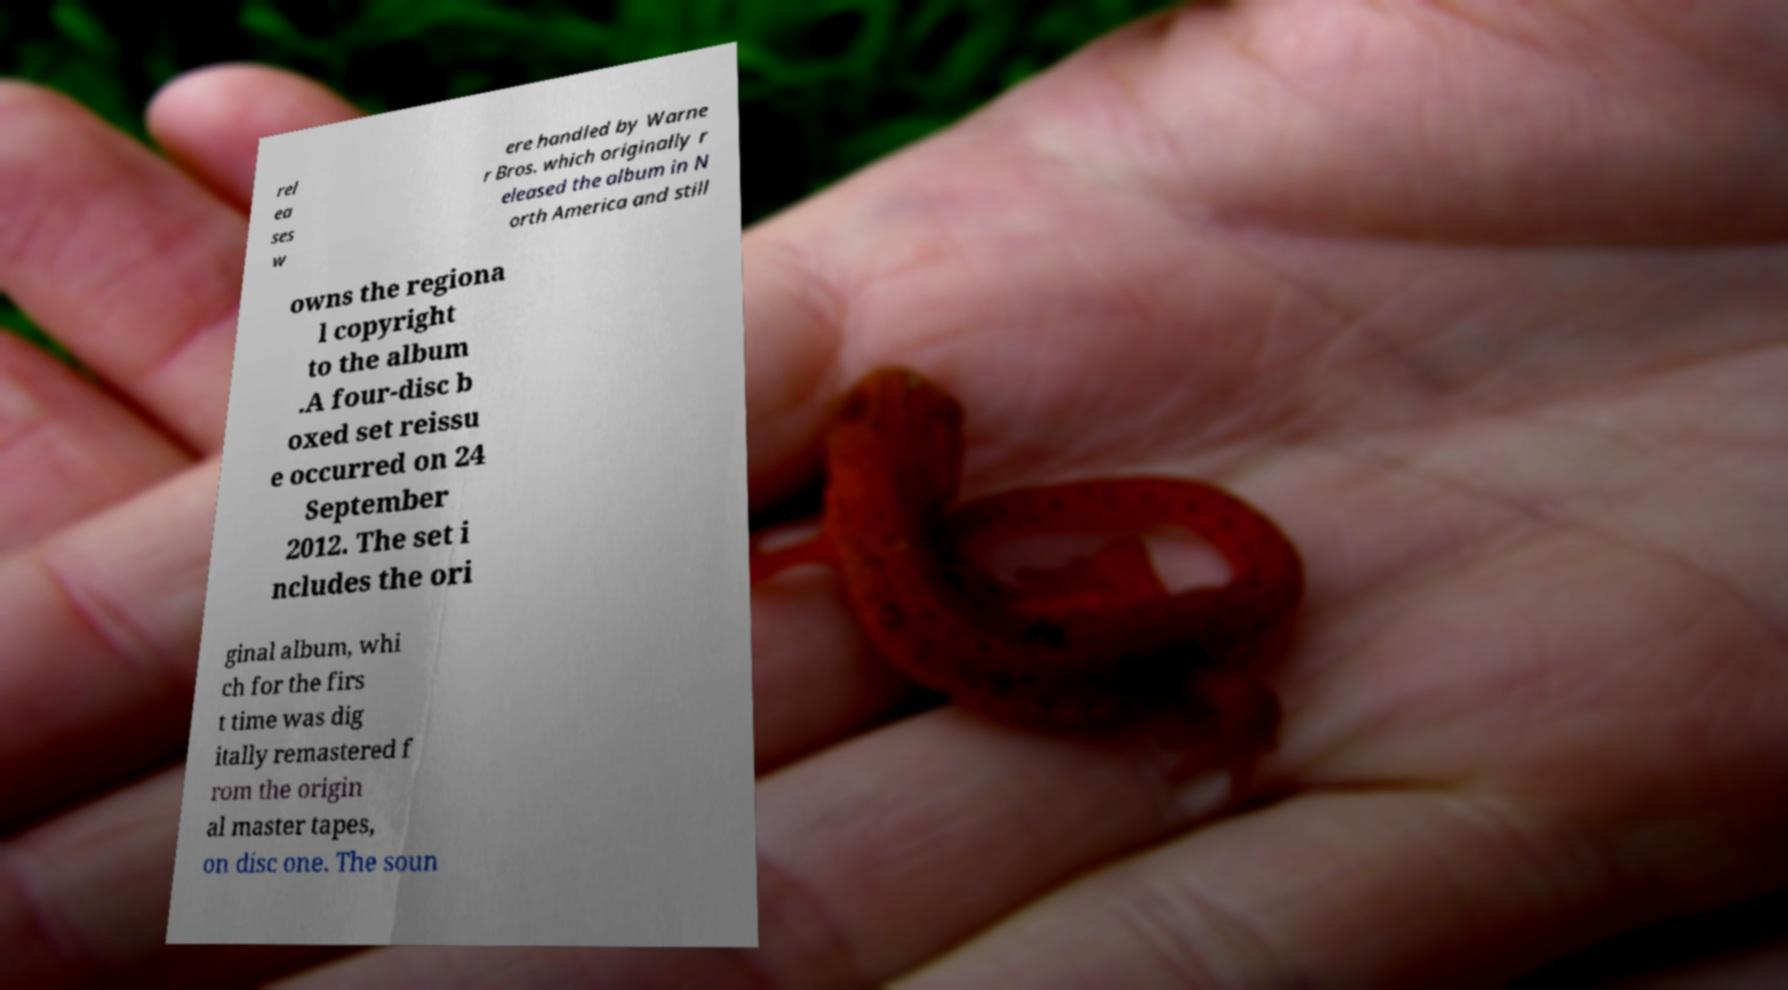Please read and relay the text visible in this image. What does it say? rel ea ses w ere handled by Warne r Bros. which originally r eleased the album in N orth America and still owns the regiona l copyright to the album .A four-disc b oxed set reissu e occurred on 24 September 2012. The set i ncludes the ori ginal album, whi ch for the firs t time was dig itally remastered f rom the origin al master tapes, on disc one. The soun 